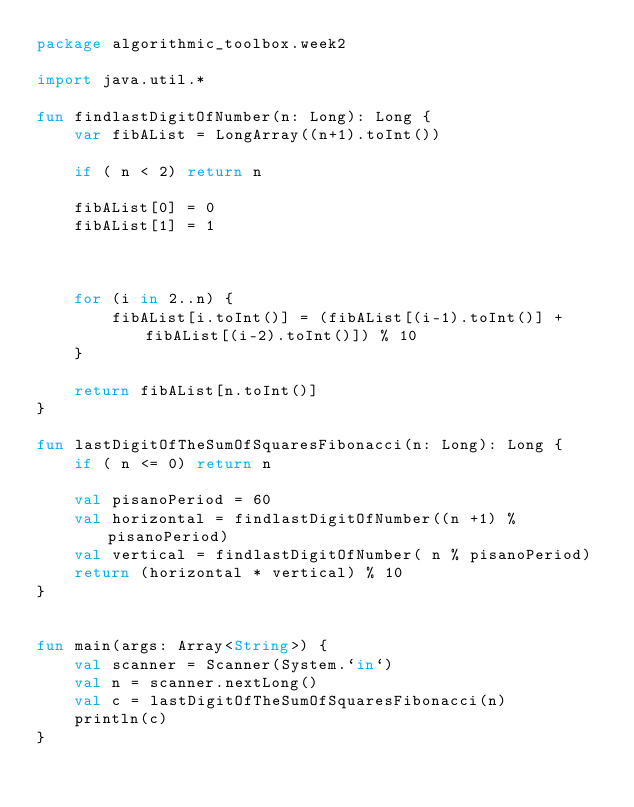<code> <loc_0><loc_0><loc_500><loc_500><_Kotlin_>package algorithmic_toolbox.week2

import java.util.*

fun findlastDigitOfNumber(n: Long): Long {
    var fibAList = LongArray((n+1).toInt())

    if ( n < 2) return n

    fibAList[0] = 0
    fibAList[1] = 1



    for (i in 2..n) {
        fibAList[i.toInt()] = (fibAList[(i-1).toInt()] + fibAList[(i-2).toInt()]) % 10
    }

    return fibAList[n.toInt()]
}

fun lastDigitOfTheSumOfSquaresFibonacci(n: Long): Long {
    if ( n <= 0) return n

    val pisanoPeriod = 60
    val horizontal = findlastDigitOfNumber((n +1) % pisanoPeriod)
    val vertical = findlastDigitOfNumber( n % pisanoPeriod)
    return (horizontal * vertical) % 10
}


fun main(args: Array<String>) {
    val scanner = Scanner(System.`in`)
    val n = scanner.nextLong()
    val c = lastDigitOfTheSumOfSquaresFibonacci(n)
    println(c)
}
</code> 